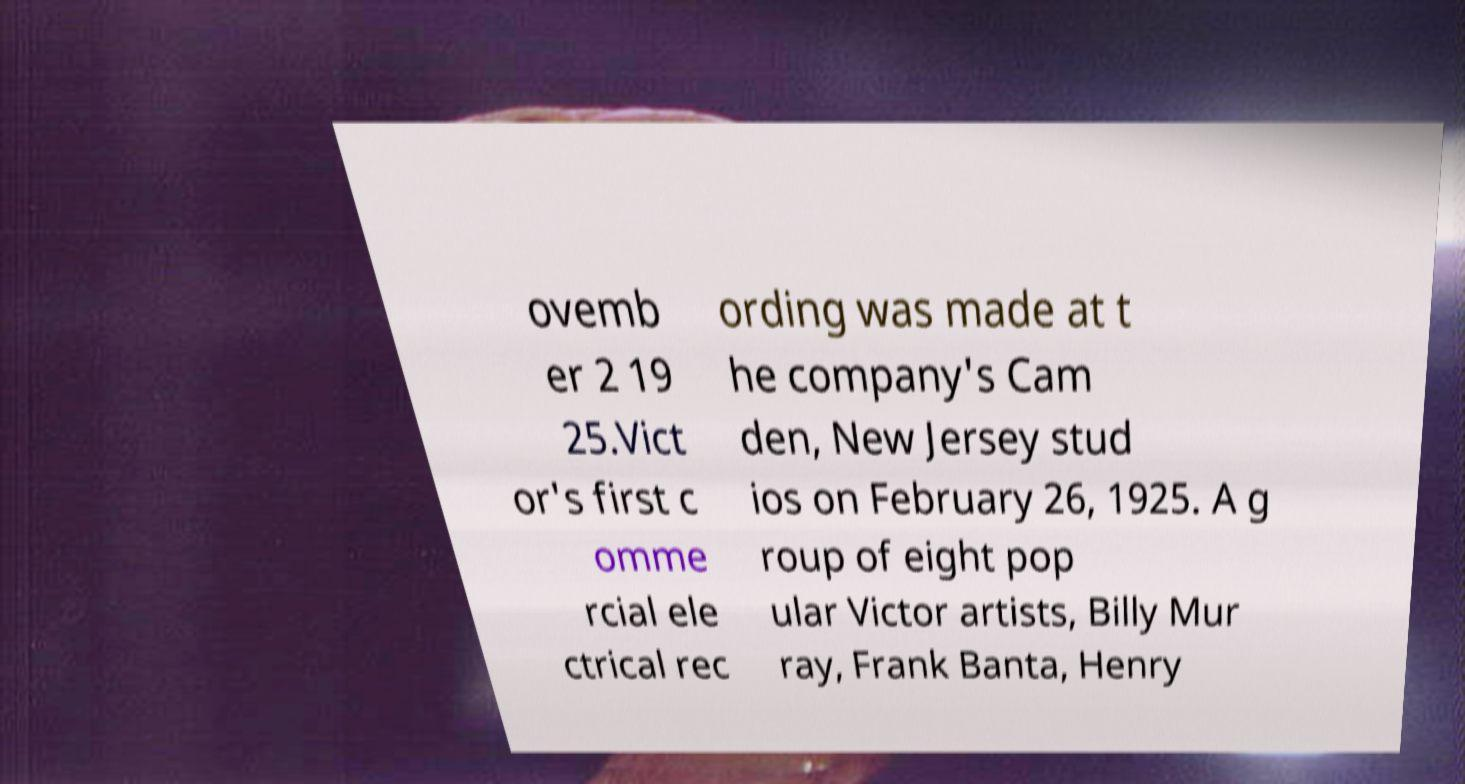For documentation purposes, I need the text within this image transcribed. Could you provide that? ovemb er 2 19 25.Vict or's first c omme rcial ele ctrical rec ording was made at t he company's Cam den, New Jersey stud ios on February 26, 1925. A g roup of eight pop ular Victor artists, Billy Mur ray, Frank Banta, Henry 